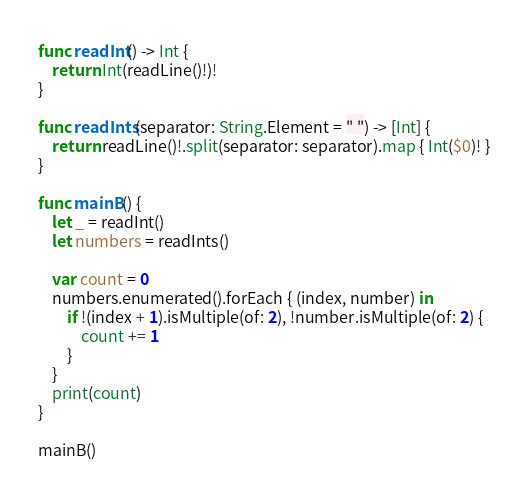<code> <loc_0><loc_0><loc_500><loc_500><_Swift_>func readInt() -> Int {
    return Int(readLine()!)!
}

func readInts(separator: String.Element = " ") -> [Int] {
    return readLine()!.split(separator: separator).map { Int($0)! }
}

func mainB() {
    let _ = readInt()
    let numbers = readInts()

    var count = 0
    numbers.enumerated().forEach { (index, number) in
        if !(index + 1).isMultiple(of: 2), !number.isMultiple(of: 2) {
            count += 1
        }
    }
    print(count)
}

mainB()</code> 